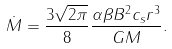<formula> <loc_0><loc_0><loc_500><loc_500>\dot { M } = \frac { 3 \sqrt { 2 \pi } } { 8 } \frac { \alpha \beta B ^ { 2 } c _ { s } r ^ { 3 } } { G M } .</formula> 